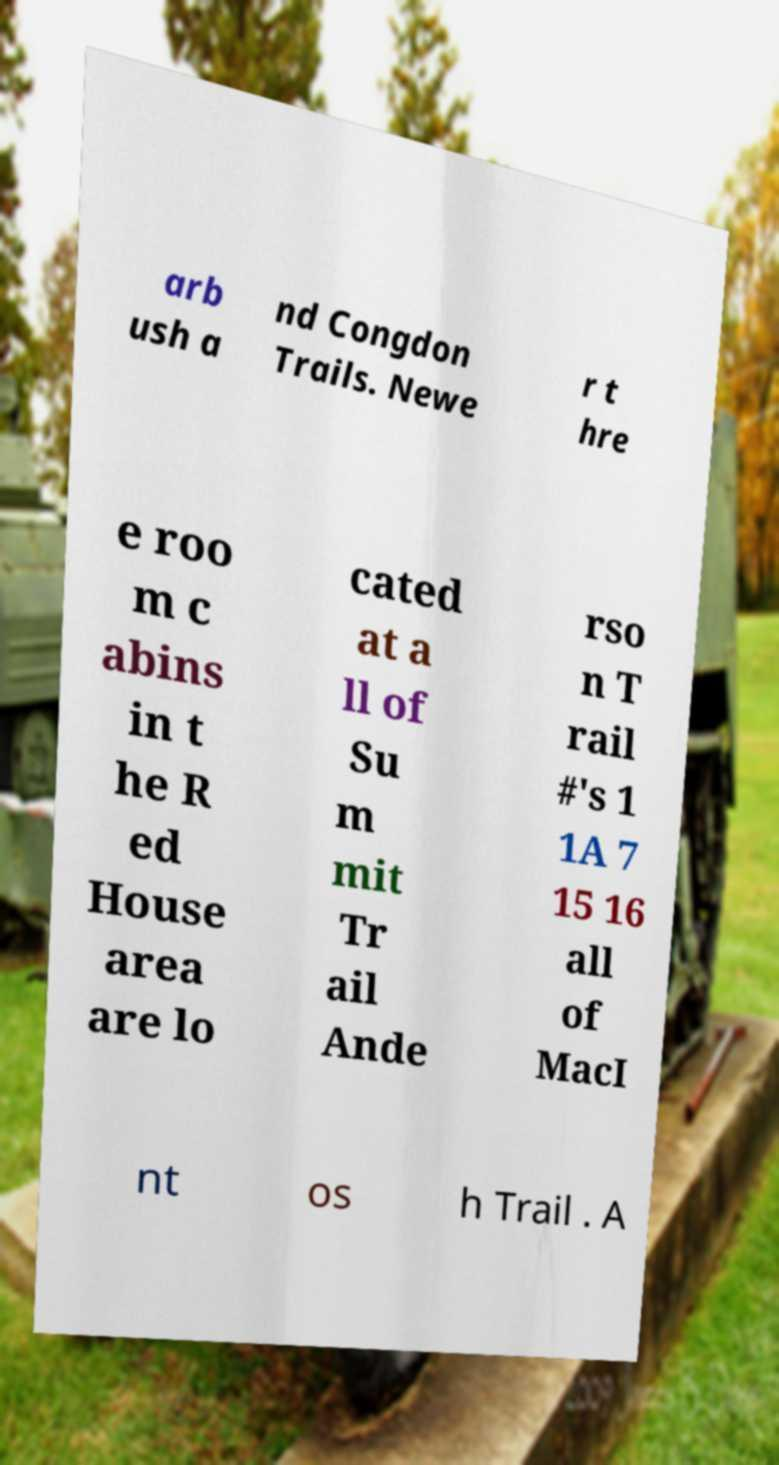I need the written content from this picture converted into text. Can you do that? arb ush a nd Congdon Trails. Newe r t hre e roo m c abins in t he R ed House area are lo cated at a ll of Su m mit Tr ail Ande rso n T rail #'s 1 1A 7 15 16 all of MacI nt os h Trail . A 